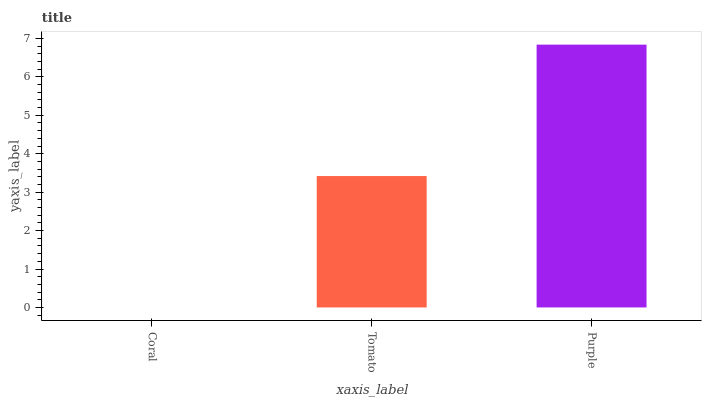Is Coral the minimum?
Answer yes or no. Yes. Is Purple the maximum?
Answer yes or no. Yes. Is Tomato the minimum?
Answer yes or no. No. Is Tomato the maximum?
Answer yes or no. No. Is Tomato greater than Coral?
Answer yes or no. Yes. Is Coral less than Tomato?
Answer yes or no. Yes. Is Coral greater than Tomato?
Answer yes or no. No. Is Tomato less than Coral?
Answer yes or no. No. Is Tomato the high median?
Answer yes or no. Yes. Is Tomato the low median?
Answer yes or no. Yes. Is Purple the high median?
Answer yes or no. No. Is Coral the low median?
Answer yes or no. No. 